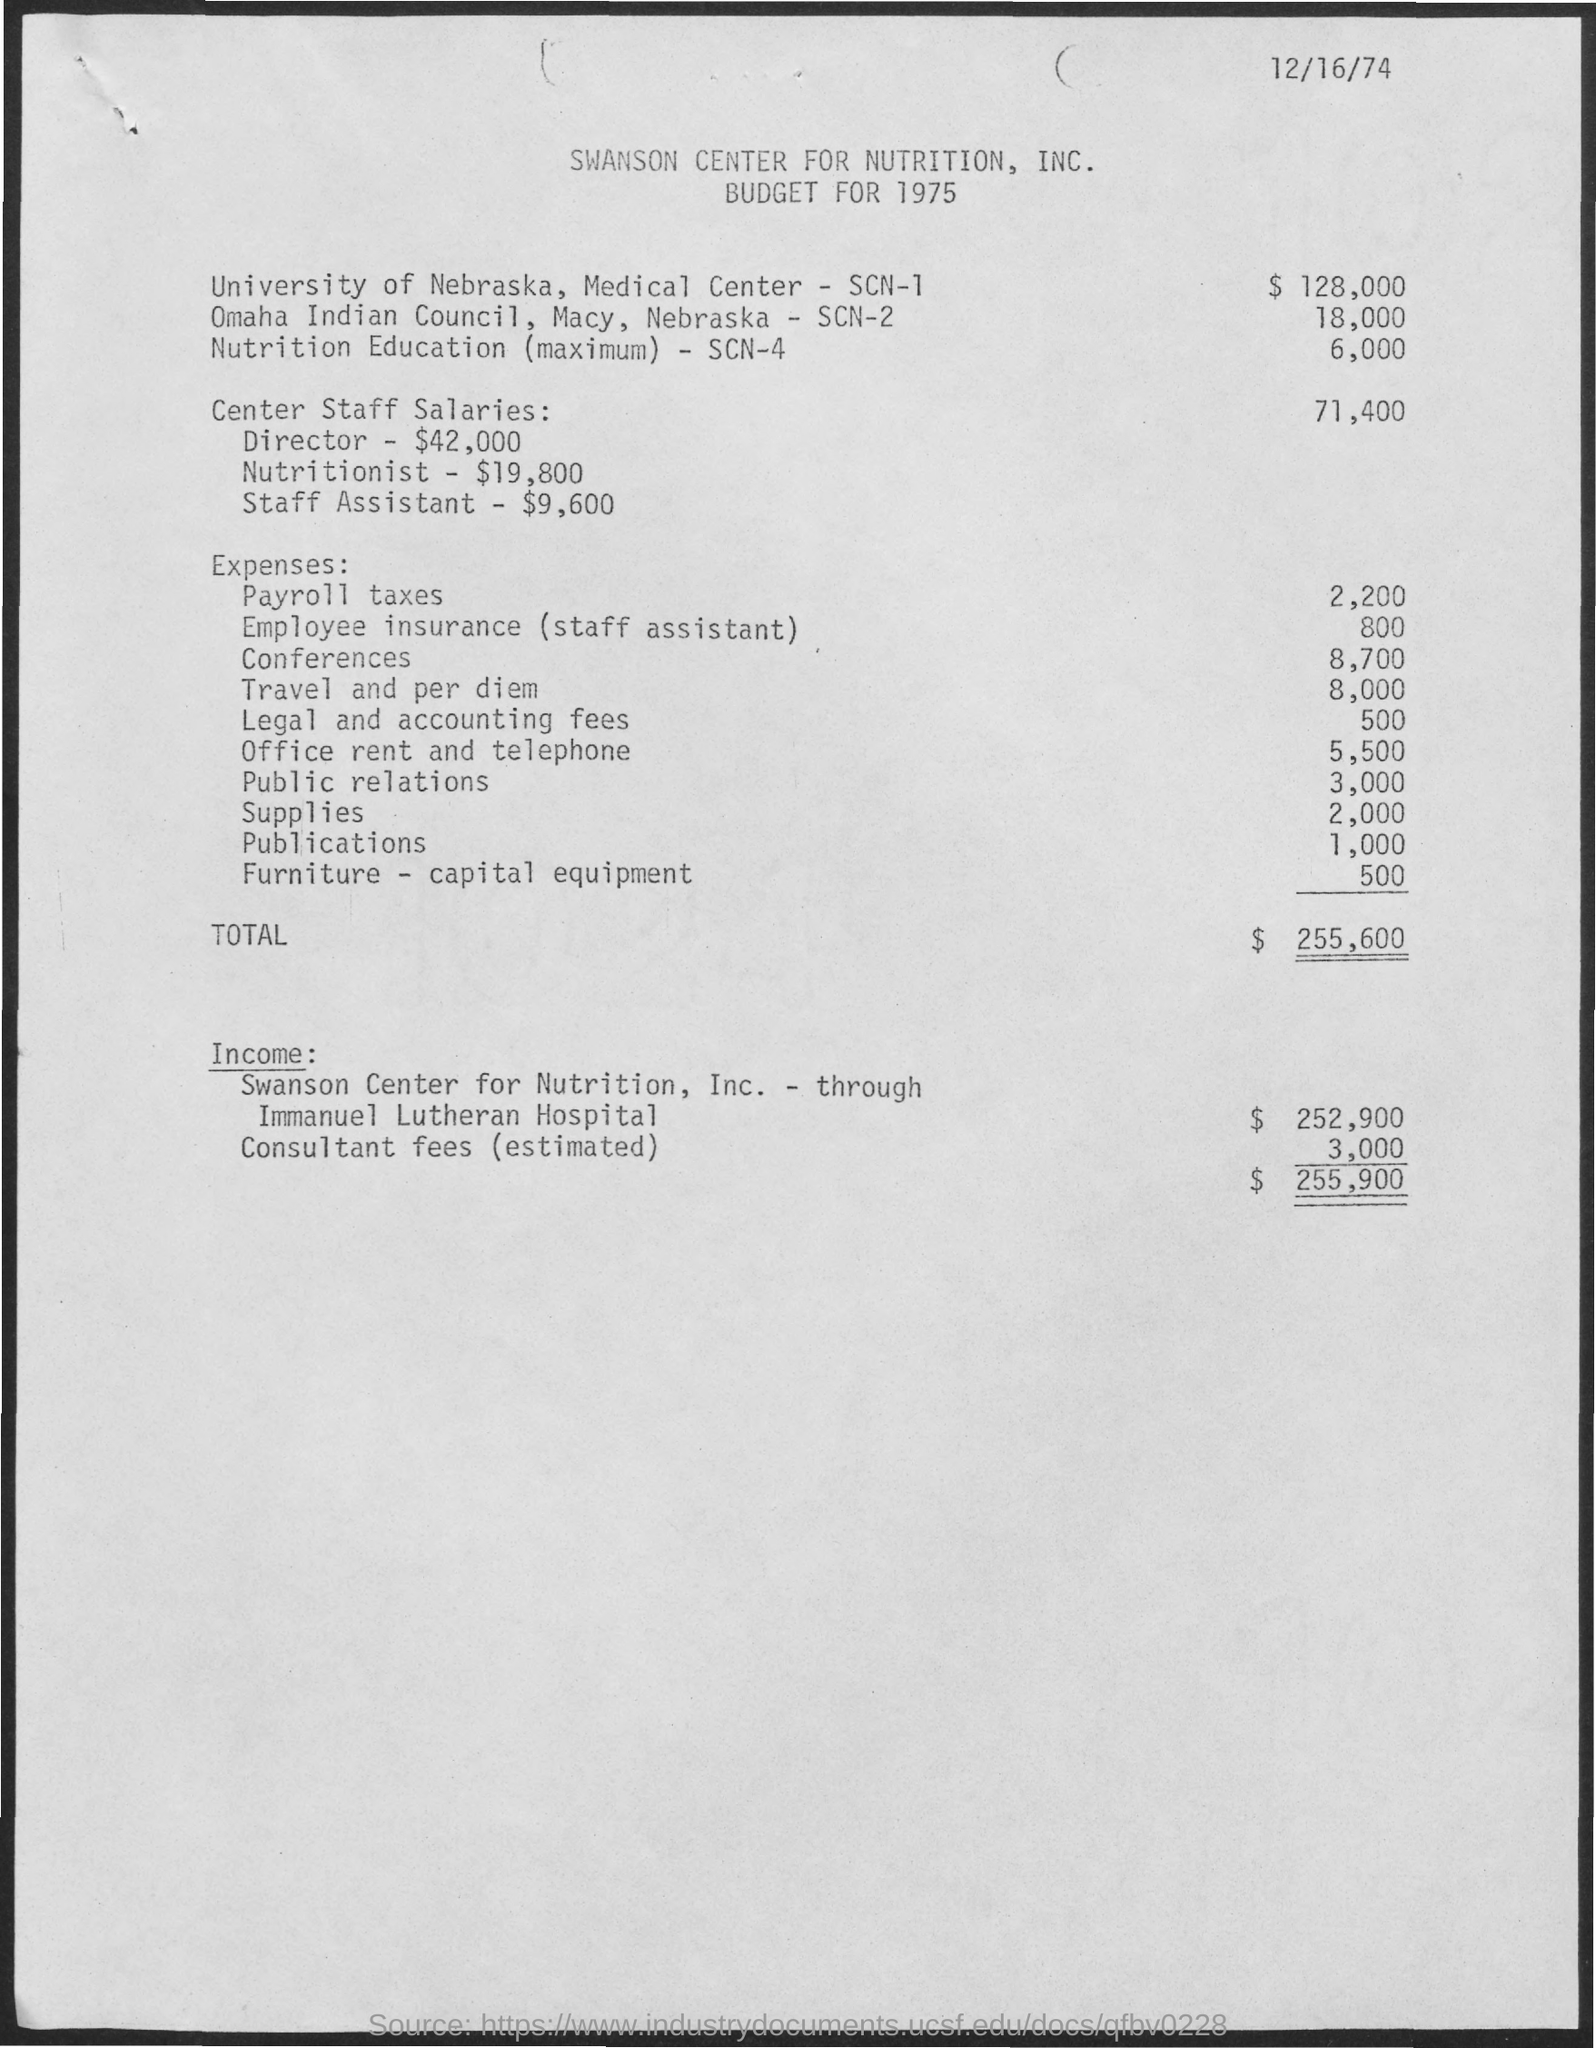Point out several critical features in this image. As of my knowledge cutoff of September 2021, the expenses for payroll taxes were approximately 2,200. The expenses for office rent and telephone are 5,500. The expenses for publications are 1,000. The expenses for travel and per diem are approximately 8,000. The expenses for conferences are approximately 8,700. 